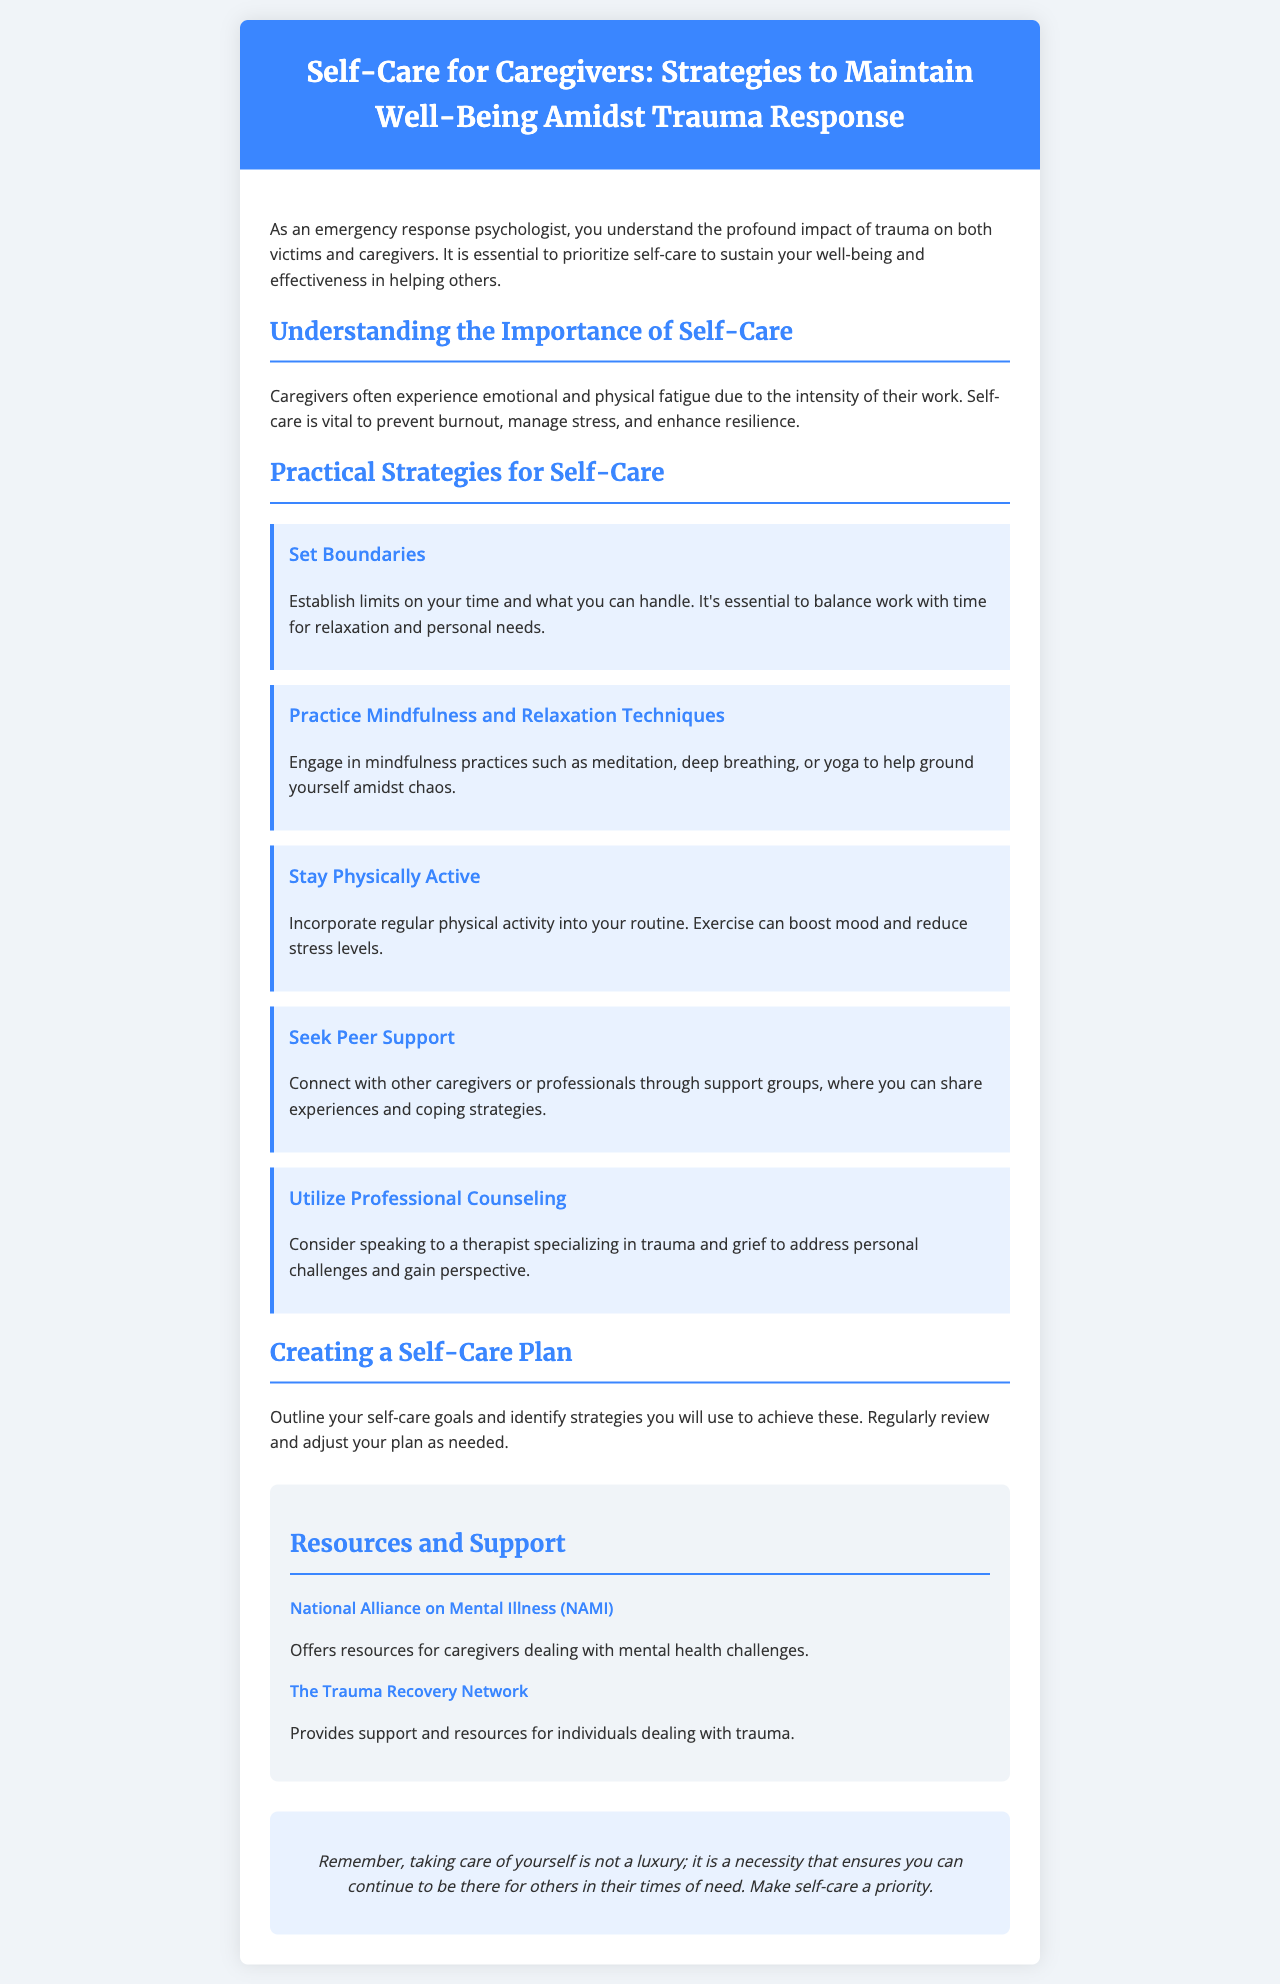What is the title of the brochure? The title of the brochure is highlighted in the header section, summarizing its focus on self-care for caregivers.
Answer: Self-Care for Caregivers: Strategies to Maintain Well-Being Amidst Trauma Response What is one reason why self-care is important for caregivers? The document emphasizes that self-care helps in preventing burnout, managing stress, and enhancing resilience.
Answer: Prevent burnout Name one strategy for self-care mentioned in the brochure. The brochure lists several strategies for self-care; one example is to set boundaries.
Answer: Set Boundaries What organization offers resources for caregivers dealing with mental health challenges? This detail is specified under the resources section of the brochure, listing organizations that provide support.
Answer: National Alliance on Mental Illness (NAMI) How many practical strategies for self-care are suggested in the document? The document outlines several strategies, which can be counted in the relevant section.
Answer: Five What should caregivers do to create a self-care plan? The brochure advises caregivers to outline goals and identify strategies, emphasizing the need for regular review and adjustment.
Answer: Outline self-care goals Which strategy encourages caregivers to connect with others? The document refers to support groups for caregivers, specifically in the context of sharing experiences and coping strategies.
Answer: Seek Peer Support What color is used for the header background? The document describes the header's visual design, including its color scheme.
Answer: Blue 